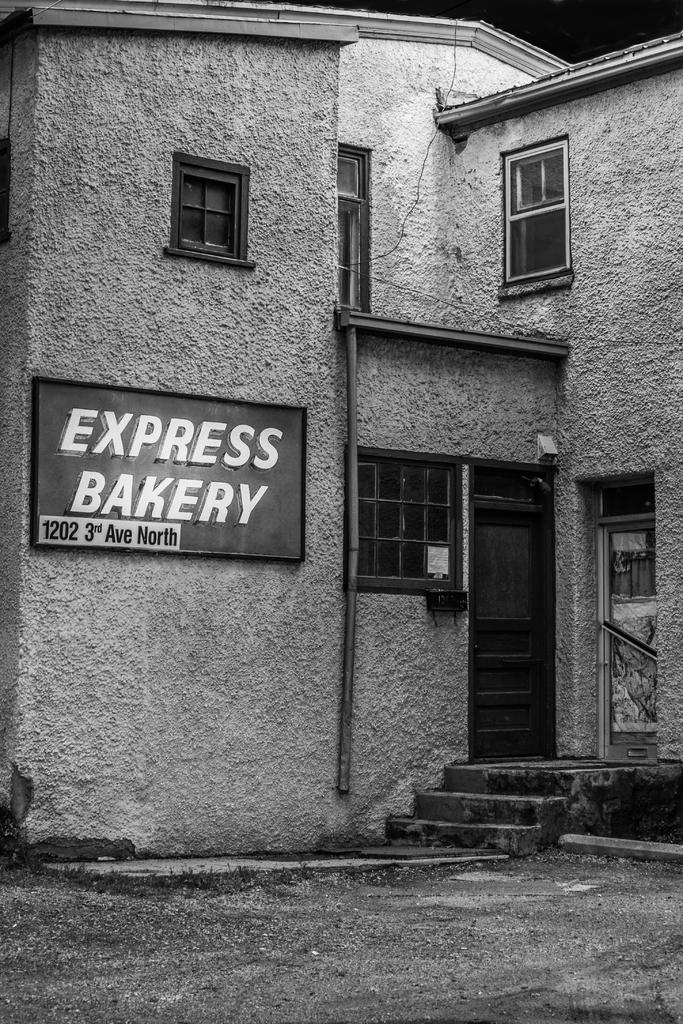What is the color scheme of the image? The image is black and white. What structure can be seen in the image? There is a house in the image. Is there any text or signage attached to the house? Yes, there is a name board attached to the house. How many brothers are playing with the squirrel in the image? There are no brothers or squirrels present in the image; it only features a house with a name board. 